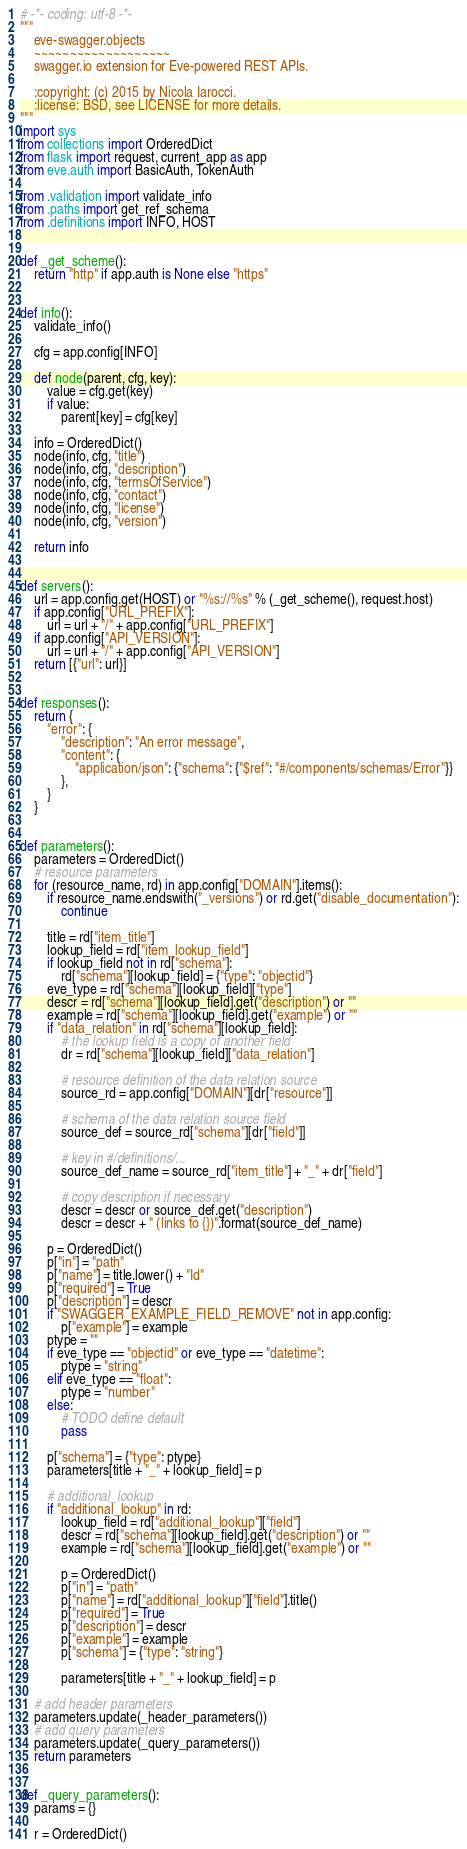<code> <loc_0><loc_0><loc_500><loc_500><_Python_># -*- coding: utf-8 -*-
"""
    eve-swagger.objects
    ~~~~~~~~~~~~~~~~~~~
    swagger.io extension for Eve-powered REST APIs.

    :copyright: (c) 2015 by Nicola Iarocci.
    :license: BSD, see LICENSE for more details.
"""
import sys
from collections import OrderedDict
from flask import request, current_app as app
from eve.auth import BasicAuth, TokenAuth

from .validation import validate_info
from .paths import get_ref_schema
from .definitions import INFO, HOST


def _get_scheme():
    return "http" if app.auth is None else "https"


def info():
    validate_info()

    cfg = app.config[INFO]

    def node(parent, cfg, key):
        value = cfg.get(key)
        if value:
            parent[key] = cfg[key]

    info = OrderedDict()
    node(info, cfg, "title")
    node(info, cfg, "description")
    node(info, cfg, "termsOfService")
    node(info, cfg, "contact")
    node(info, cfg, "license")
    node(info, cfg, "version")

    return info


def servers():
    url = app.config.get(HOST) or "%s://%s" % (_get_scheme(), request.host)
    if app.config["URL_PREFIX"]:
        url = url + "/" + app.config["URL_PREFIX"]
    if app.config["API_VERSION"]:
        url = url + "/" + app.config["API_VERSION"]
    return [{"url": url}]


def responses():
    return {
        "error": {
            "description": "An error message",
            "content": {
                "application/json": {"schema": {"$ref": "#/components/schemas/Error"}}
            },
        }
    }


def parameters():
    parameters = OrderedDict()
    # resource parameters
    for (resource_name, rd) in app.config["DOMAIN"].items():
        if resource_name.endswith("_versions") or rd.get("disable_documentation"):
            continue

        title = rd["item_title"]
        lookup_field = rd["item_lookup_field"]
        if lookup_field not in rd["schema"]:
            rd["schema"][lookup_field] = {"type": "objectid"}
        eve_type = rd["schema"][lookup_field]["type"]
        descr = rd["schema"][lookup_field].get("description") or ""
        example = rd["schema"][lookup_field].get("example") or ""
        if "data_relation" in rd["schema"][lookup_field]:
            # the lookup field is a copy of another field
            dr = rd["schema"][lookup_field]["data_relation"]

            # resource definition of the data relation source
            source_rd = app.config["DOMAIN"][dr["resource"]]

            # schema of the data relation source field
            source_def = source_rd["schema"][dr["field"]]

            # key in #/definitions/...
            source_def_name = source_rd["item_title"] + "_" + dr["field"]

            # copy description if necessary
            descr = descr or source_def.get("description")
            descr = descr + " (links to {})".format(source_def_name)

        p = OrderedDict()
        p["in"] = "path"
        p["name"] = title.lower() + "Id"
        p["required"] = True
        p["description"] = descr
        if "SWAGGER_EXAMPLE_FIELD_REMOVE" not in app.config:
            p["example"] = example
        ptype = ""
        if eve_type == "objectid" or eve_type == "datetime":
            ptype = "string"
        elif eve_type == "float":
            ptype = "number"
        else:
            # TODO define default
            pass

        p["schema"] = {"type": ptype}
        parameters[title + "_" + lookup_field] = p

        # additional_lookup
        if "additional_lookup" in rd:
            lookup_field = rd["additional_lookup"]["field"]
            descr = rd["schema"][lookup_field].get("description") or ""
            example = rd["schema"][lookup_field].get("example") or ""

            p = OrderedDict()
            p["in"] = "path"
            p["name"] = rd["additional_lookup"]["field"].title()
            p["required"] = True
            p["description"] = descr
            p["example"] = example
            p["schema"] = {"type": "string"}

            parameters[title + "_" + lookup_field] = p

    # add header parameters
    parameters.update(_header_parameters())
    # add query parameters
    parameters.update(_query_parameters())
    return parameters


def _query_parameters():
    params = {}

    r = OrderedDict()</code> 